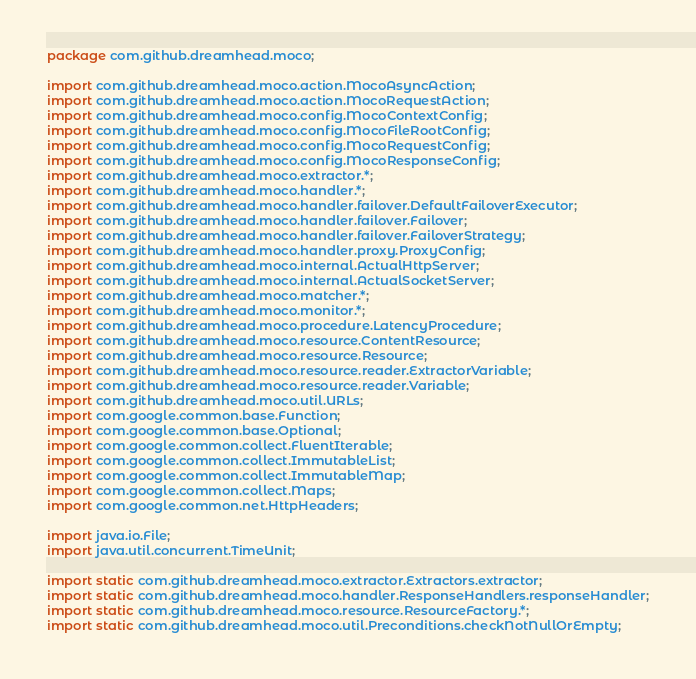Convert code to text. <code><loc_0><loc_0><loc_500><loc_500><_Java_>package com.github.dreamhead.moco;

import com.github.dreamhead.moco.action.MocoAsyncAction;
import com.github.dreamhead.moco.action.MocoRequestAction;
import com.github.dreamhead.moco.config.MocoContextConfig;
import com.github.dreamhead.moco.config.MocoFileRootConfig;
import com.github.dreamhead.moco.config.MocoRequestConfig;
import com.github.dreamhead.moco.config.MocoResponseConfig;
import com.github.dreamhead.moco.extractor.*;
import com.github.dreamhead.moco.handler.*;
import com.github.dreamhead.moco.handler.failover.DefaultFailoverExecutor;
import com.github.dreamhead.moco.handler.failover.Failover;
import com.github.dreamhead.moco.handler.failover.FailoverStrategy;
import com.github.dreamhead.moco.handler.proxy.ProxyConfig;
import com.github.dreamhead.moco.internal.ActualHttpServer;
import com.github.dreamhead.moco.internal.ActualSocketServer;
import com.github.dreamhead.moco.matcher.*;
import com.github.dreamhead.moco.monitor.*;
import com.github.dreamhead.moco.procedure.LatencyProcedure;
import com.github.dreamhead.moco.resource.ContentResource;
import com.github.dreamhead.moco.resource.Resource;
import com.github.dreamhead.moco.resource.reader.ExtractorVariable;
import com.github.dreamhead.moco.resource.reader.Variable;
import com.github.dreamhead.moco.util.URLs;
import com.google.common.base.Function;
import com.google.common.base.Optional;
import com.google.common.collect.FluentIterable;
import com.google.common.collect.ImmutableList;
import com.google.common.collect.ImmutableMap;
import com.google.common.collect.Maps;
import com.google.common.net.HttpHeaders;

import java.io.File;
import java.util.concurrent.TimeUnit;

import static com.github.dreamhead.moco.extractor.Extractors.extractor;
import static com.github.dreamhead.moco.handler.ResponseHandlers.responseHandler;
import static com.github.dreamhead.moco.resource.ResourceFactory.*;
import static com.github.dreamhead.moco.util.Preconditions.checkNotNullOrEmpty;</code> 